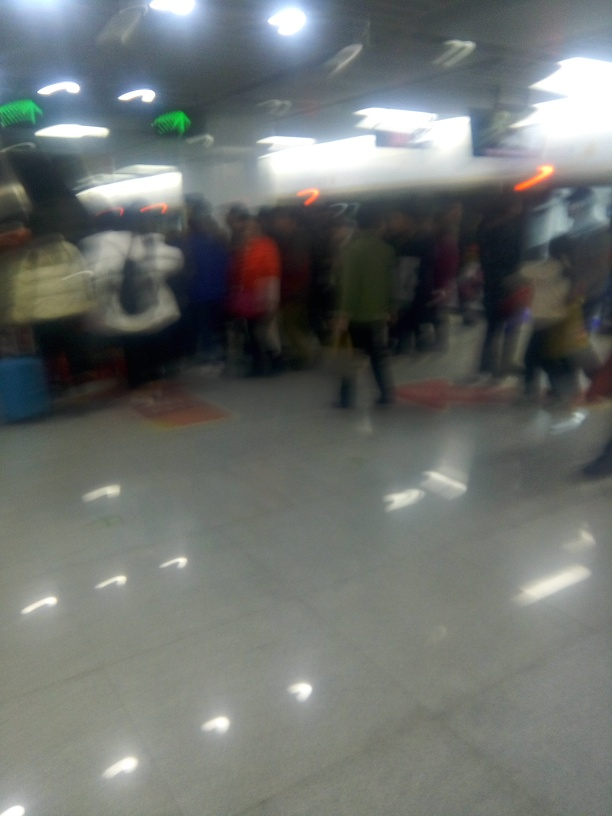How could someone improve the quality of a photo like this in the future? To improve photo quality, one could use a camera with image stabilization, hold the camera steady perhaps with a tripod, ensure proper focus before taking the shot, and use a quicker shutter speed to reduce motion blur, especially in low-light conditions. 